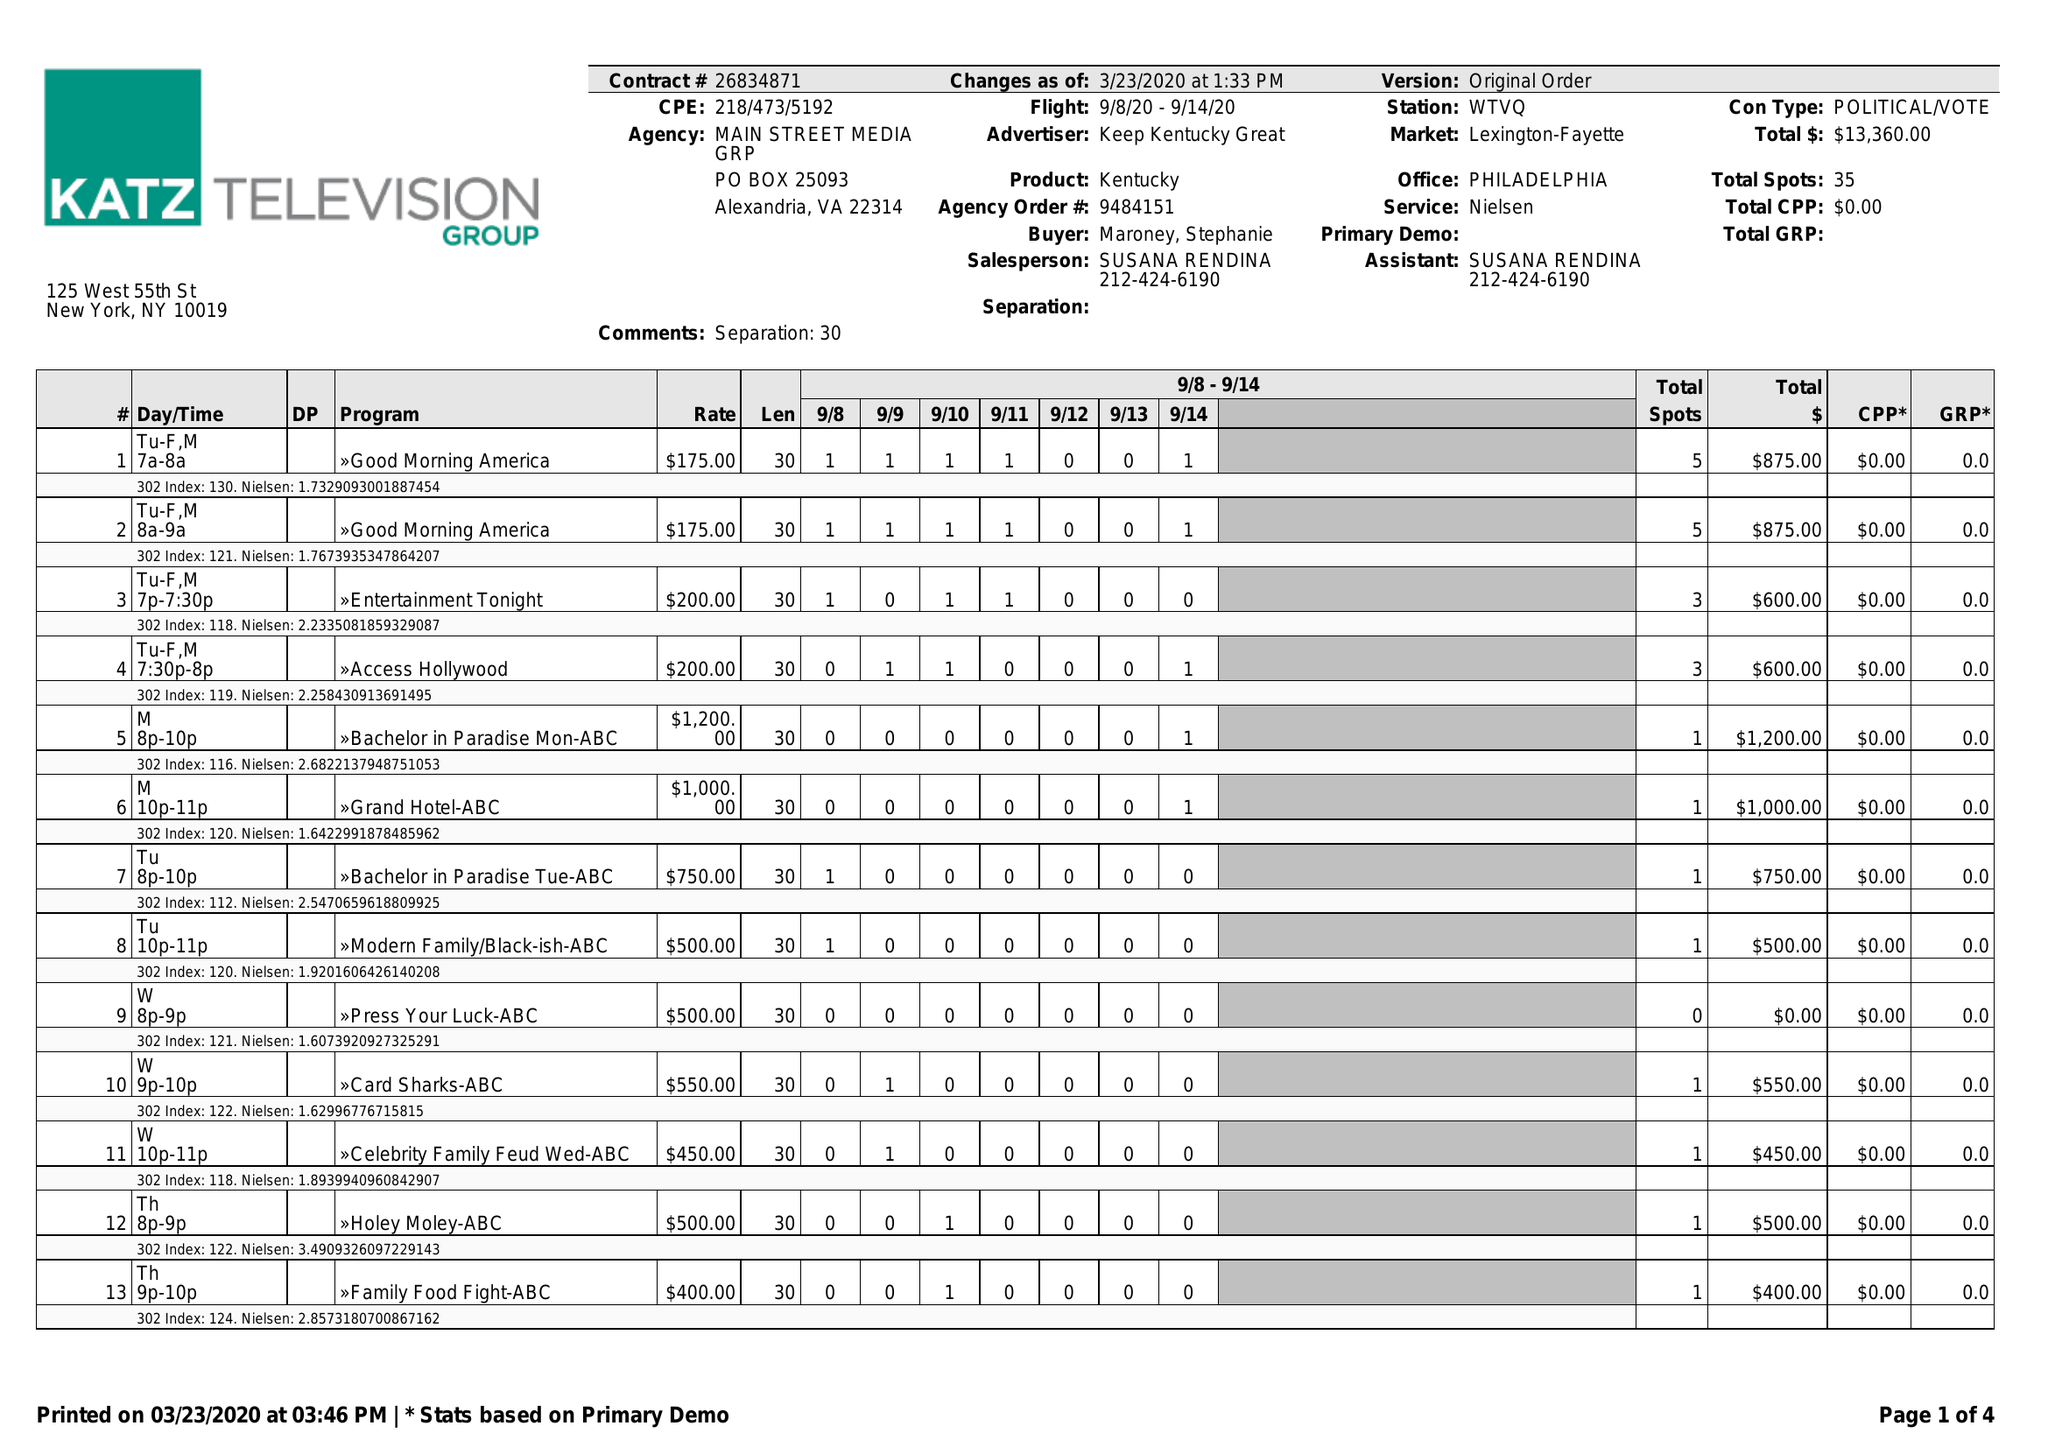What is the value for the advertiser?
Answer the question using a single word or phrase. KEEP KENTUCKY GREAT 